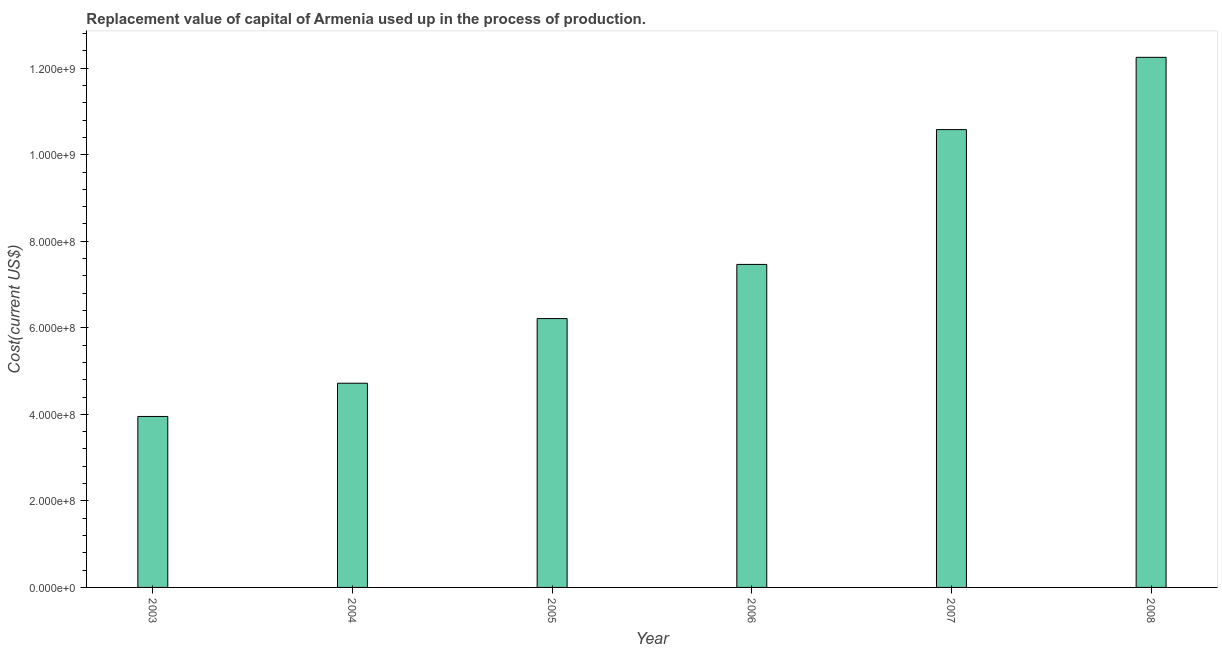Does the graph contain any zero values?
Your response must be concise. No. What is the title of the graph?
Your answer should be compact. Replacement value of capital of Armenia used up in the process of production. What is the label or title of the Y-axis?
Give a very brief answer. Cost(current US$). What is the consumption of fixed capital in 2004?
Your response must be concise. 4.72e+08. Across all years, what is the maximum consumption of fixed capital?
Make the answer very short. 1.23e+09. Across all years, what is the minimum consumption of fixed capital?
Provide a short and direct response. 3.95e+08. In which year was the consumption of fixed capital maximum?
Provide a succinct answer. 2008. What is the sum of the consumption of fixed capital?
Provide a succinct answer. 4.52e+09. What is the difference between the consumption of fixed capital in 2004 and 2008?
Offer a terse response. -7.53e+08. What is the average consumption of fixed capital per year?
Ensure brevity in your answer.  7.53e+08. What is the median consumption of fixed capital?
Your answer should be compact. 6.84e+08. What is the ratio of the consumption of fixed capital in 2004 to that in 2005?
Offer a terse response. 0.76. Is the consumption of fixed capital in 2004 less than that in 2008?
Your answer should be very brief. Yes. Is the difference between the consumption of fixed capital in 2003 and 2004 greater than the difference between any two years?
Provide a short and direct response. No. What is the difference between the highest and the second highest consumption of fixed capital?
Your answer should be very brief. 1.67e+08. What is the difference between the highest and the lowest consumption of fixed capital?
Provide a succinct answer. 8.30e+08. In how many years, is the consumption of fixed capital greater than the average consumption of fixed capital taken over all years?
Provide a short and direct response. 2. Are all the bars in the graph horizontal?
Your answer should be very brief. No. Are the values on the major ticks of Y-axis written in scientific E-notation?
Make the answer very short. Yes. What is the Cost(current US$) of 2003?
Offer a very short reply. 3.95e+08. What is the Cost(current US$) of 2004?
Your answer should be compact. 4.72e+08. What is the Cost(current US$) in 2005?
Make the answer very short. 6.21e+08. What is the Cost(current US$) in 2006?
Provide a succinct answer. 7.46e+08. What is the Cost(current US$) in 2007?
Offer a terse response. 1.06e+09. What is the Cost(current US$) of 2008?
Your answer should be compact. 1.23e+09. What is the difference between the Cost(current US$) in 2003 and 2004?
Your answer should be very brief. -7.68e+07. What is the difference between the Cost(current US$) in 2003 and 2005?
Provide a succinct answer. -2.26e+08. What is the difference between the Cost(current US$) in 2003 and 2006?
Provide a succinct answer. -3.51e+08. What is the difference between the Cost(current US$) in 2003 and 2007?
Your response must be concise. -6.63e+08. What is the difference between the Cost(current US$) in 2003 and 2008?
Your response must be concise. -8.30e+08. What is the difference between the Cost(current US$) in 2004 and 2005?
Provide a short and direct response. -1.49e+08. What is the difference between the Cost(current US$) in 2004 and 2006?
Provide a succinct answer. -2.75e+08. What is the difference between the Cost(current US$) in 2004 and 2007?
Make the answer very short. -5.86e+08. What is the difference between the Cost(current US$) in 2004 and 2008?
Keep it short and to the point. -7.53e+08. What is the difference between the Cost(current US$) in 2005 and 2006?
Your answer should be compact. -1.25e+08. What is the difference between the Cost(current US$) in 2005 and 2007?
Provide a succinct answer. -4.37e+08. What is the difference between the Cost(current US$) in 2005 and 2008?
Your response must be concise. -6.04e+08. What is the difference between the Cost(current US$) in 2006 and 2007?
Your answer should be very brief. -3.12e+08. What is the difference between the Cost(current US$) in 2006 and 2008?
Ensure brevity in your answer.  -4.79e+08. What is the difference between the Cost(current US$) in 2007 and 2008?
Ensure brevity in your answer.  -1.67e+08. What is the ratio of the Cost(current US$) in 2003 to that in 2004?
Offer a terse response. 0.84. What is the ratio of the Cost(current US$) in 2003 to that in 2005?
Ensure brevity in your answer.  0.64. What is the ratio of the Cost(current US$) in 2003 to that in 2006?
Give a very brief answer. 0.53. What is the ratio of the Cost(current US$) in 2003 to that in 2007?
Offer a terse response. 0.37. What is the ratio of the Cost(current US$) in 2003 to that in 2008?
Make the answer very short. 0.32. What is the ratio of the Cost(current US$) in 2004 to that in 2005?
Ensure brevity in your answer.  0.76. What is the ratio of the Cost(current US$) in 2004 to that in 2006?
Make the answer very short. 0.63. What is the ratio of the Cost(current US$) in 2004 to that in 2007?
Offer a terse response. 0.45. What is the ratio of the Cost(current US$) in 2004 to that in 2008?
Offer a very short reply. 0.39. What is the ratio of the Cost(current US$) in 2005 to that in 2006?
Keep it short and to the point. 0.83. What is the ratio of the Cost(current US$) in 2005 to that in 2007?
Your answer should be compact. 0.59. What is the ratio of the Cost(current US$) in 2005 to that in 2008?
Provide a succinct answer. 0.51. What is the ratio of the Cost(current US$) in 2006 to that in 2007?
Offer a terse response. 0.71. What is the ratio of the Cost(current US$) in 2006 to that in 2008?
Offer a terse response. 0.61. What is the ratio of the Cost(current US$) in 2007 to that in 2008?
Give a very brief answer. 0.86. 